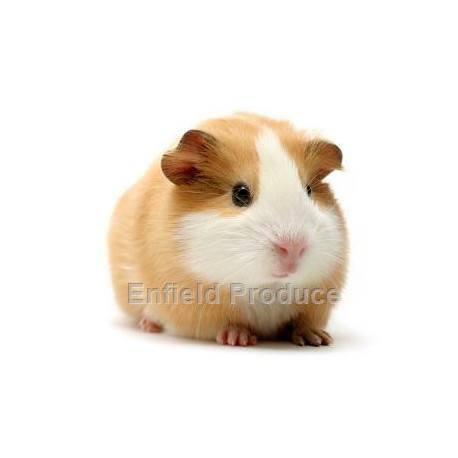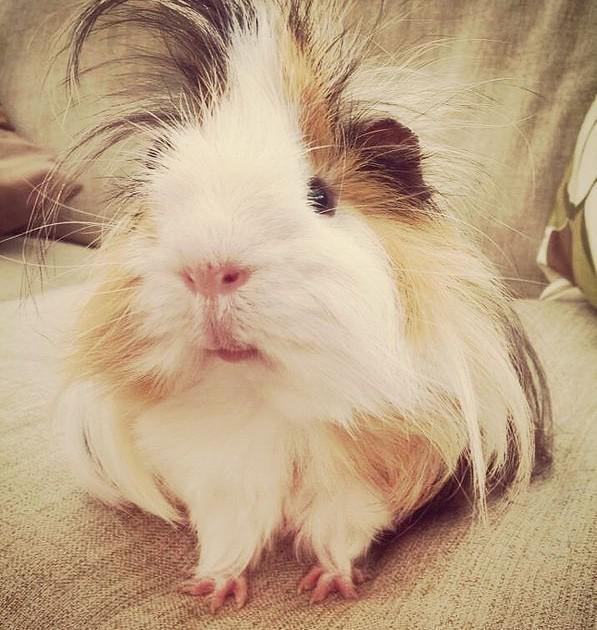The first image is the image on the left, the second image is the image on the right. Assess this claim about the two images: "There is no brown fur on these guinea pigs.". Correct or not? Answer yes or no. No. 